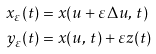<formula> <loc_0><loc_0><loc_500><loc_500>x _ { \varepsilon } ( t ) & = x ( u + \varepsilon \Delta u , \, t ) \\ y _ { \varepsilon } ( t ) & = x ( u , \, t ) + \varepsilon z ( t )</formula> 